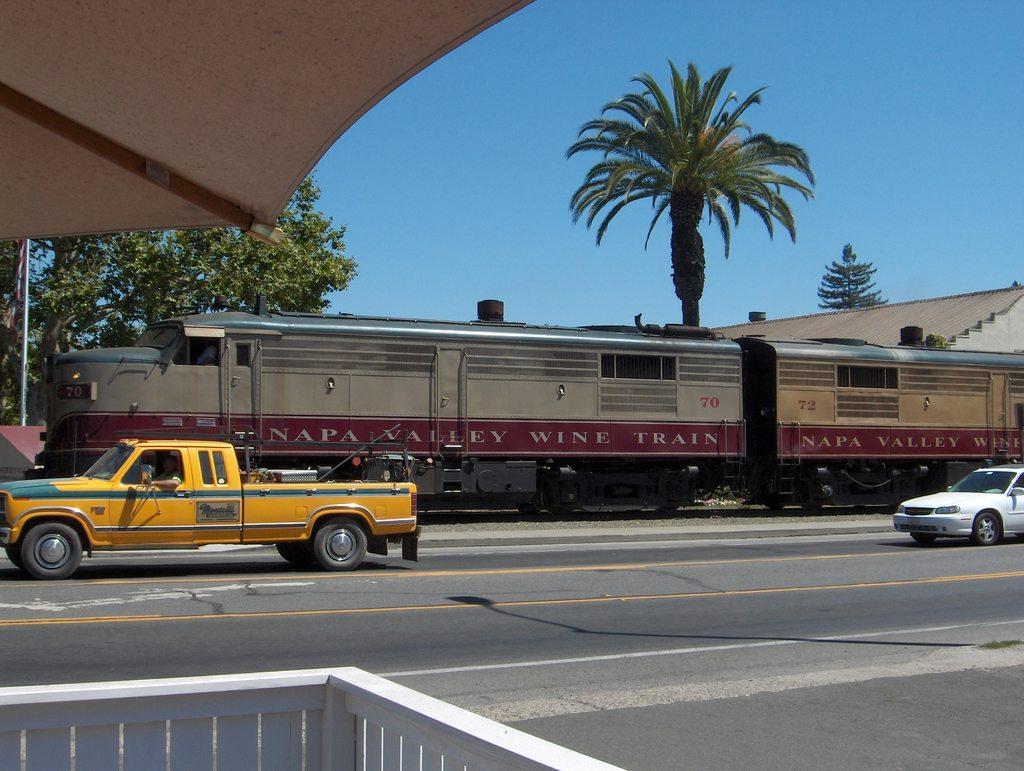Can you describe this image briefly? This image is clicked on a street, there is a car and truck going on road and behind it there is a train moving on train track followed by trees and house in the background and above its sky. 